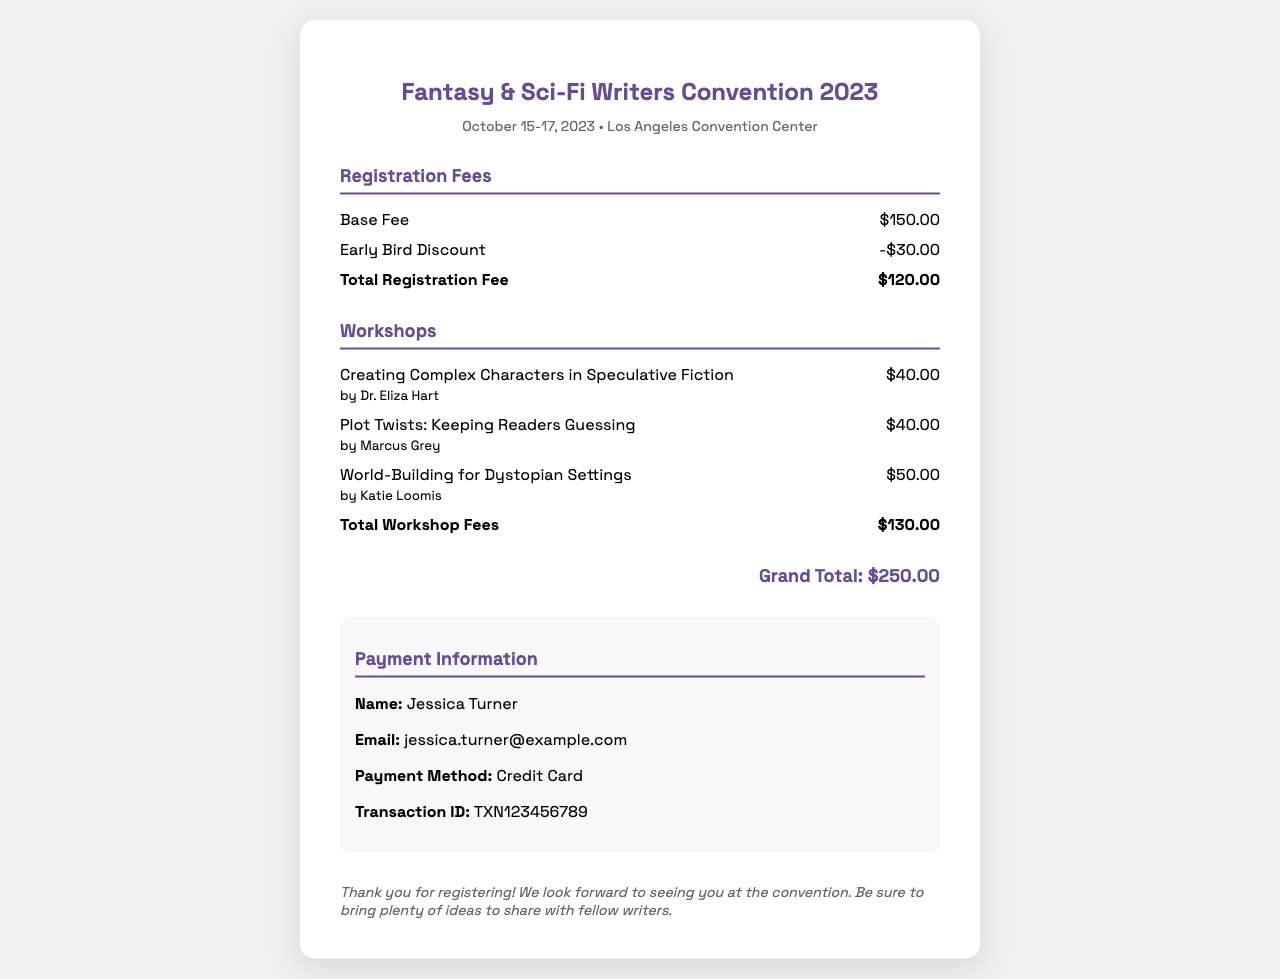What is the base registration fee? The base registration fee listed in the document is $150.00.
Answer: $150.00 What is the total registration fee after the early bird discount? The total registration fee after applying the early bird discount is $120.00.
Answer: $120.00 Who is the instructor for the "Plot Twists: Keeping Readers Guessing" workshop? The instructor for this workshop is Marcus Grey.
Answer: Marcus Grey How much do the workshops cost in total? The total cost for all the workshops combined is $130.00.
Answer: $130.00 What is the grand total of the ticket and workshops? The grand total for the ticket and workshops combined is $250.00.
Answer: $250.00 What is the payment method used for the registration? The payment method specified in the document is Credit Card.
Answer: Credit Card When does the Fantasy & Sci-Fi Writers Convention take place? The convention takes place on October 15-17, 2023.
Answer: October 15-17, 2023 Who is the participant registered for this event? The registered participant's name given in the document is Jessica Turner.
Answer: Jessica Turner 